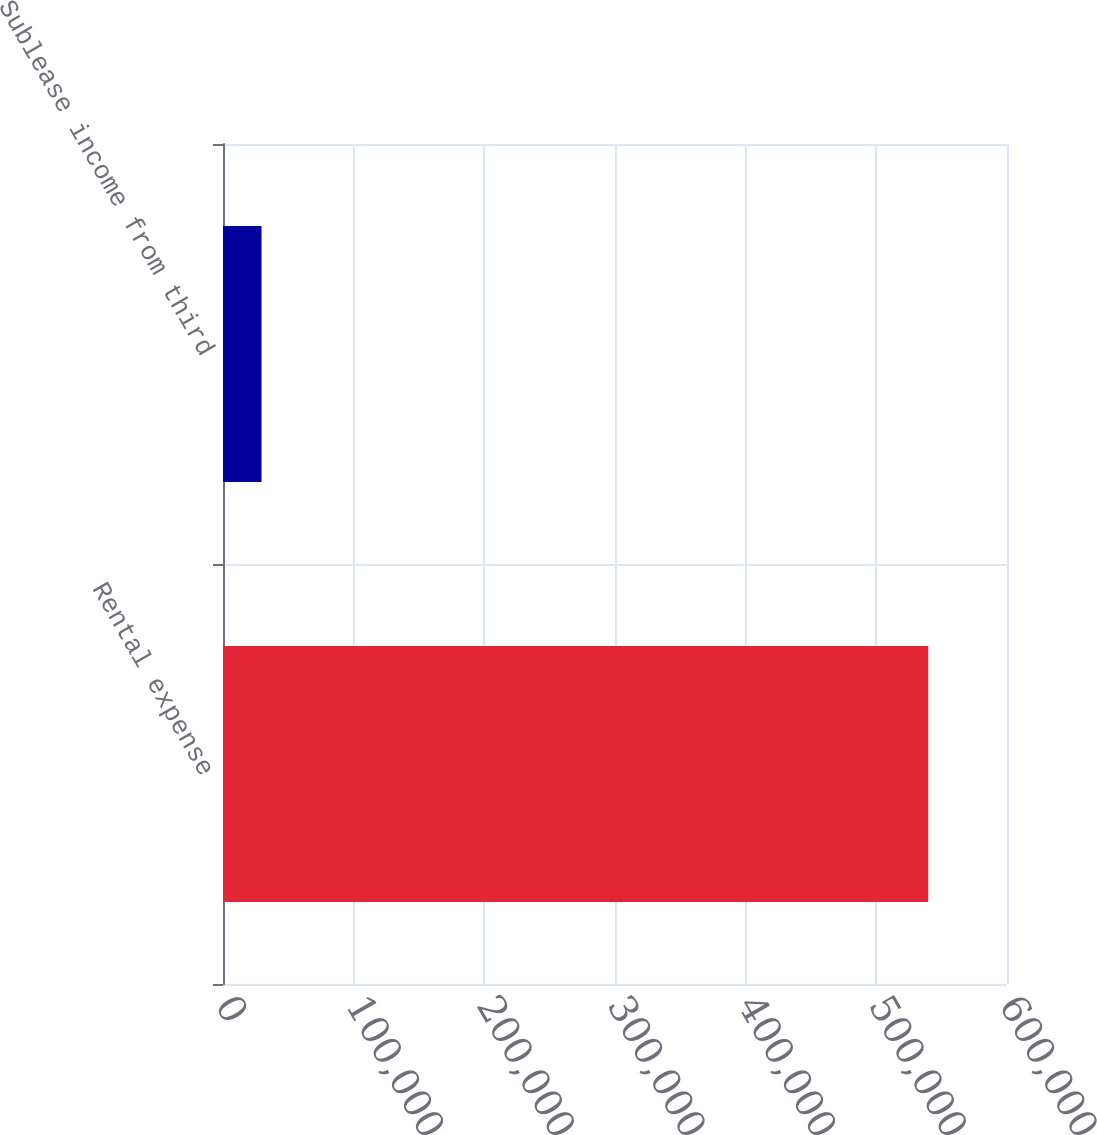<chart> <loc_0><loc_0><loc_500><loc_500><bar_chart><fcel>Rental expense<fcel>Sublease income from third<nl><fcel>539711<fcel>29482<nl></chart> 